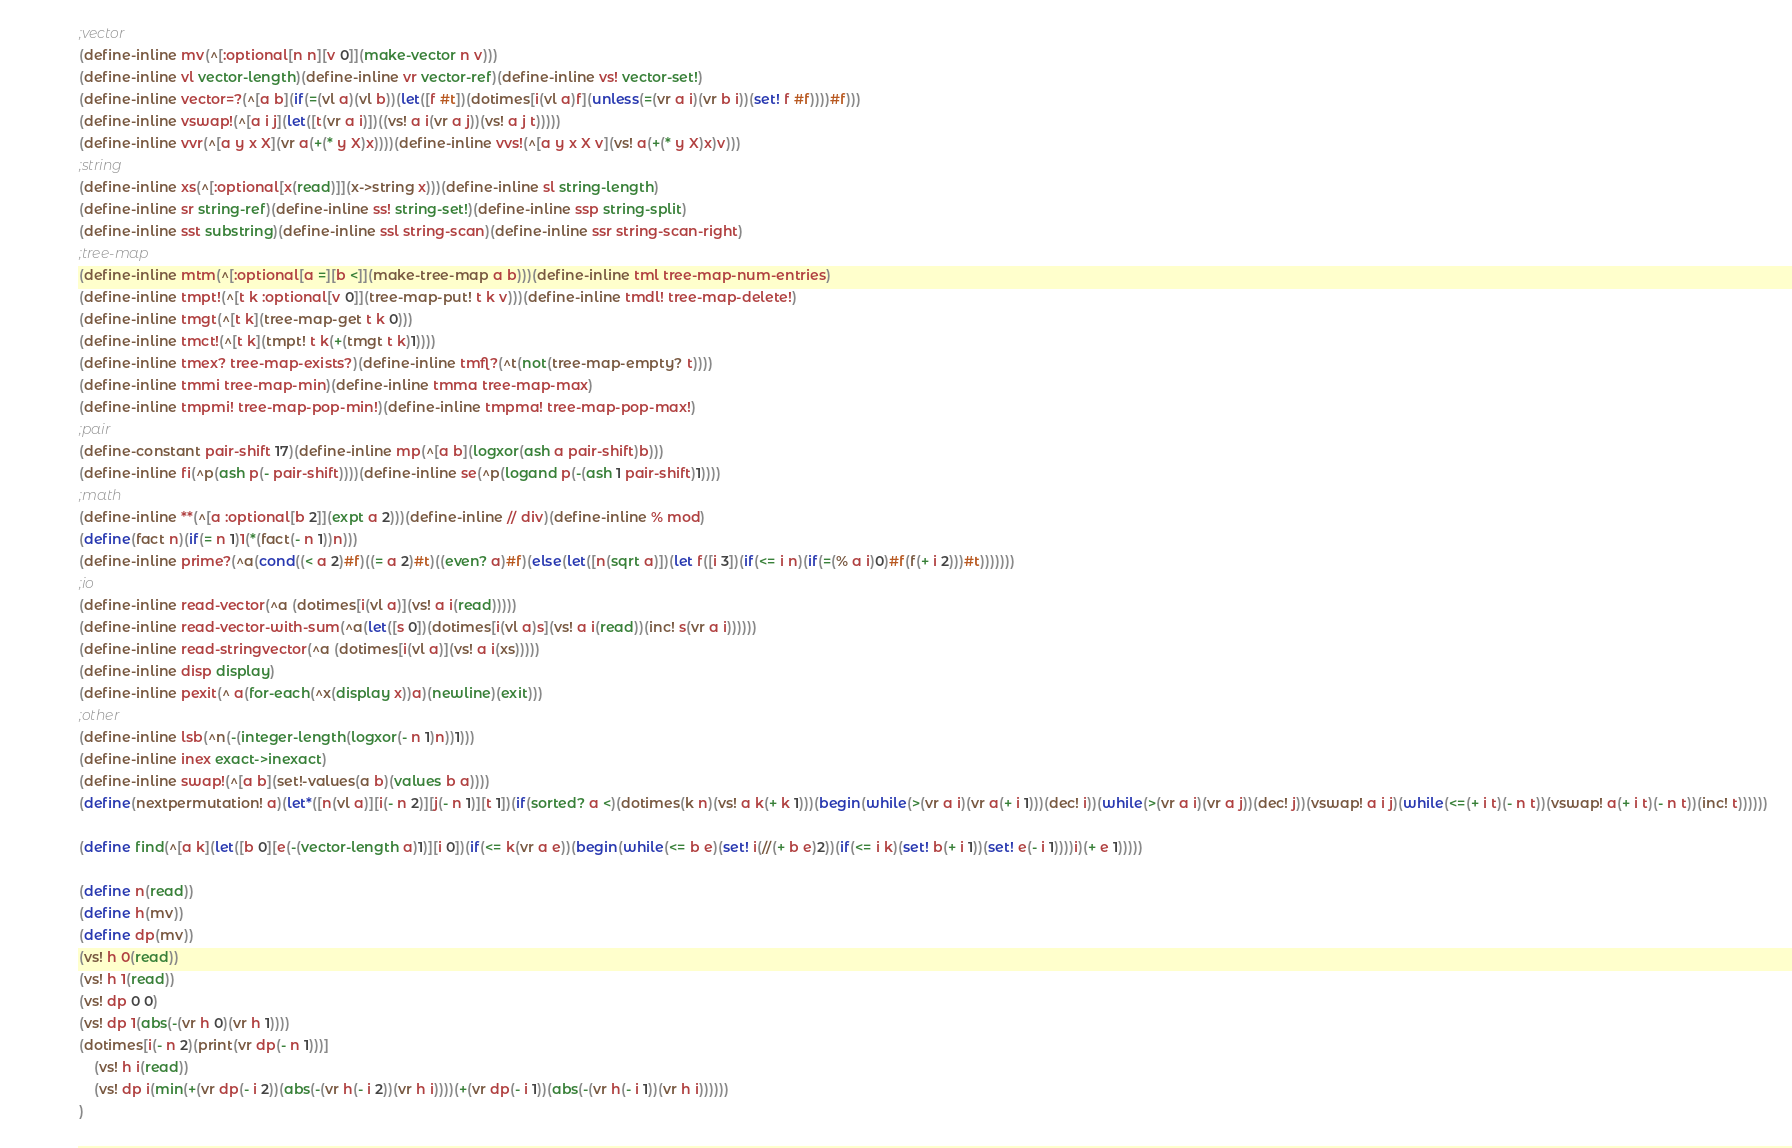<code> <loc_0><loc_0><loc_500><loc_500><_Scheme_>;vector
(define-inline mv(^[:optional[n n][v 0]](make-vector n v)))
(define-inline vl vector-length)(define-inline vr vector-ref)(define-inline vs! vector-set!)
(define-inline vector=?(^[a b](if(=(vl a)(vl b))(let([f #t])(dotimes[i(vl a)f](unless(=(vr a i)(vr b i))(set! f #f))))#f)))
(define-inline vswap!(^[a i j](let([t(vr a i)])((vs! a i(vr a j))(vs! a j t)))))
(define-inline vvr(^[a y x X](vr a(+(* y X)x))))(define-inline vvs!(^[a y x X v](vs! a(+(* y X)x)v)))
;string
(define-inline xs(^[:optional[x(read)]](x->string x)))(define-inline sl string-length)
(define-inline sr string-ref)(define-inline ss! string-set!)(define-inline ssp string-split)
(define-inline sst substring)(define-inline ssl string-scan)(define-inline ssr string-scan-right)
;tree-map
(define-inline mtm(^[:optional[a =][b <]](make-tree-map a b)))(define-inline tml tree-map-num-entries)
(define-inline tmpt!(^[t k :optional[v 0]](tree-map-put! t k v)))(define-inline tmdl! tree-map-delete!)
(define-inline tmgt(^[t k](tree-map-get t k 0)))
(define-inline tmct!(^[t k](tmpt! t k(+(tmgt t k)1))))
(define-inline tmex? tree-map-exists?)(define-inline tmfl?(^t(not(tree-map-empty? t))))
(define-inline tmmi tree-map-min)(define-inline tmma tree-map-max)
(define-inline tmpmi! tree-map-pop-min!)(define-inline tmpma! tree-map-pop-max!)
;pair
(define-constant pair-shift 17)(define-inline mp(^[a b](logxor(ash a pair-shift)b)))
(define-inline fi(^p(ash p(- pair-shift))))(define-inline se(^p(logand p(-(ash 1 pair-shift)1))))
;math
(define-inline **(^[a :optional[b 2]](expt a 2)))(define-inline // div)(define-inline % mod)
(define(fact n)(if(= n 1)1(*(fact(- n 1))n)))
(define-inline prime?(^a(cond((< a 2)#f)((= a 2)#t)((even? a)#f)(else(let([n(sqrt a)])(let f([i 3])(if(<= i n)(if(=(% a i)0)#f(f(+ i 2)))#t)))))))
;io
(define-inline read-vector(^a (dotimes[i(vl a)](vs! a i(read)))))
(define-inline read-vector-with-sum(^a(let([s 0])(dotimes[i(vl a)s](vs! a i(read))(inc! s(vr a i))))))
(define-inline read-stringvector(^a (dotimes[i(vl a)](vs! a i(xs)))))
(define-inline disp display)
(define-inline pexit(^ a(for-each(^x(display x))a)(newline)(exit)))
;other
(define-inline lsb(^n(-(integer-length(logxor(- n 1)n))1)))
(define-inline inex exact->inexact)
(define-inline swap!(^[a b](set!-values(a b)(values b a))))
(define(nextpermutation! a)(let*([n(vl a)][i(- n 2)][j(- n 1)][t 1])(if(sorted? a <)(dotimes(k n)(vs! a k(+ k 1)))(begin(while(>(vr a i)(vr a(+ i 1)))(dec! i))(while(>(vr a i)(vr a j))(dec! j))(vswap! a i j)(while(<=(+ i t)(- n t))(vswap! a(+ i t)(- n t))(inc! t))))))

(define find(^[a k](let([b 0][e(-(vector-length a)1)][i 0])(if(<= k(vr a e))(begin(while(<= b e)(set! i(//(+ b e)2))(if(<= i k)(set! b(+ i 1))(set! e(- i 1))))i)(+ e 1)))))

(define n(read))
(define h(mv))
(define dp(mv))
(vs! h 0(read))
(vs! h 1(read))
(vs! dp 0 0)
(vs! dp 1(abs(-(vr h 0)(vr h 1))))
(dotimes[i(- n 2)(print(vr dp(- n 1)))]
	(vs! h i(read))
	(vs! dp i(min(+(vr dp(- i 2))(abs(-(vr h(- i 2))(vr h i))))(+(vr dp(- i 1))(abs(-(vr h(- i 1))(vr h i))))))
)</code> 